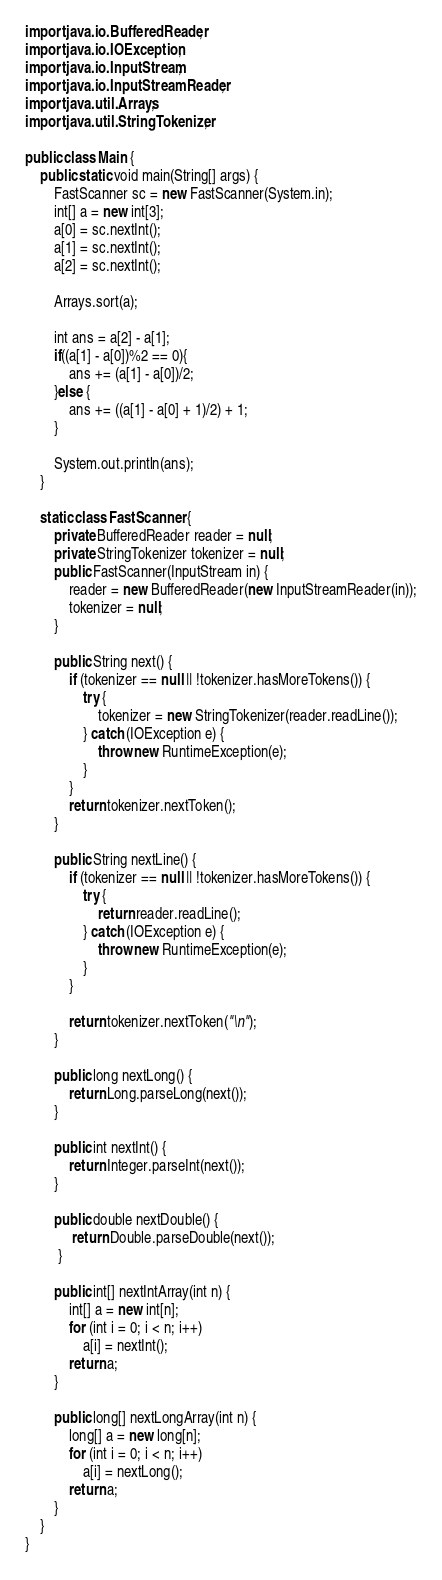<code> <loc_0><loc_0><loc_500><loc_500><_Java_>import java.io.BufferedReader;
import java.io.IOException;
import java.io.InputStream;
import java.io.InputStreamReader;
import java.util.Arrays;
import java.util.StringTokenizer;

public class Main {
	public static void main(String[] args) {
		FastScanner sc = new FastScanner(System.in);
		int[] a = new int[3];
		a[0] = sc.nextInt();
		a[1] = sc.nextInt();
		a[2] = sc.nextInt();

		Arrays.sort(a);

		int ans = a[2] - a[1];
		if((a[1] - a[0])%2 == 0){
			ans += (a[1] - a[0])/2;
		}else {
			ans += ((a[1] - a[0] + 1)/2) + 1;
		}

		System.out.println(ans);
	}

	static class FastScanner {
		private BufferedReader reader = null;
	    private StringTokenizer tokenizer = null;
	    public FastScanner(InputStream in) {
	        reader = new BufferedReader(new InputStreamReader(in));
	        tokenizer = null;
	    }

	    public String next() {
	        if (tokenizer == null || !tokenizer.hasMoreTokens()) {
	            try {
	                tokenizer = new StringTokenizer(reader.readLine());
	            } catch (IOException e) {
	                throw new RuntimeException(e);
	            }
	        }
	        return tokenizer.nextToken();
	    }

	    public String nextLine() {
	        if (tokenizer == null || !tokenizer.hasMoreTokens()) {
	            try {
	                return reader.readLine();
	            } catch (IOException e) {
	                throw new RuntimeException(e);
	            }
	        }

	        return tokenizer.nextToken("\n");
	    }

	    public long nextLong() {
	        return Long.parseLong(next());
	    }

	    public int nextInt() {
	        return Integer.parseInt(next());
	    }

	    public double nextDouble() {
	         return Double.parseDouble(next());
	     }

	    public int[] nextIntArray(int n) {
	        int[] a = new int[n];
	        for (int i = 0; i < n; i++)
	            a[i] = nextInt();
	        return a;
	    }

	    public long[] nextLongArray(int n) {
	        long[] a = new long[n];
	        for (int i = 0; i < n; i++)
	            a[i] = nextLong();
	        return a;
	    }
	}
}
</code> 